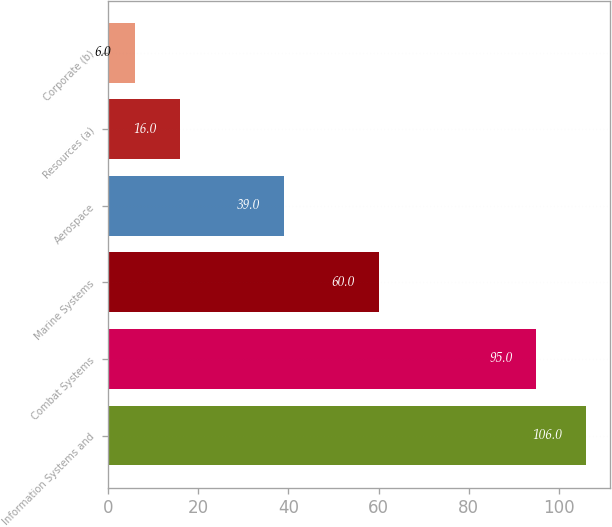Convert chart to OTSL. <chart><loc_0><loc_0><loc_500><loc_500><bar_chart><fcel>Information Systems and<fcel>Combat Systems<fcel>Marine Systems<fcel>Aerospace<fcel>Resources (a)<fcel>Corporate (b)<nl><fcel>106<fcel>95<fcel>60<fcel>39<fcel>16<fcel>6<nl></chart> 